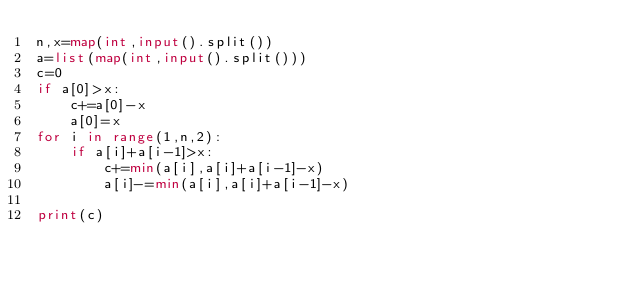<code> <loc_0><loc_0><loc_500><loc_500><_Python_>n,x=map(int,input().split())
a=list(map(int,input().split()))
c=0
if a[0]>x:
    c+=a[0]-x
    a[0]=x
for i in range(1,n,2):
    if a[i]+a[i-1]>x:
        c+=min(a[i],a[i]+a[i-1]-x)
        a[i]-=min(a[i],a[i]+a[i-1]-x)

print(c)
</code> 